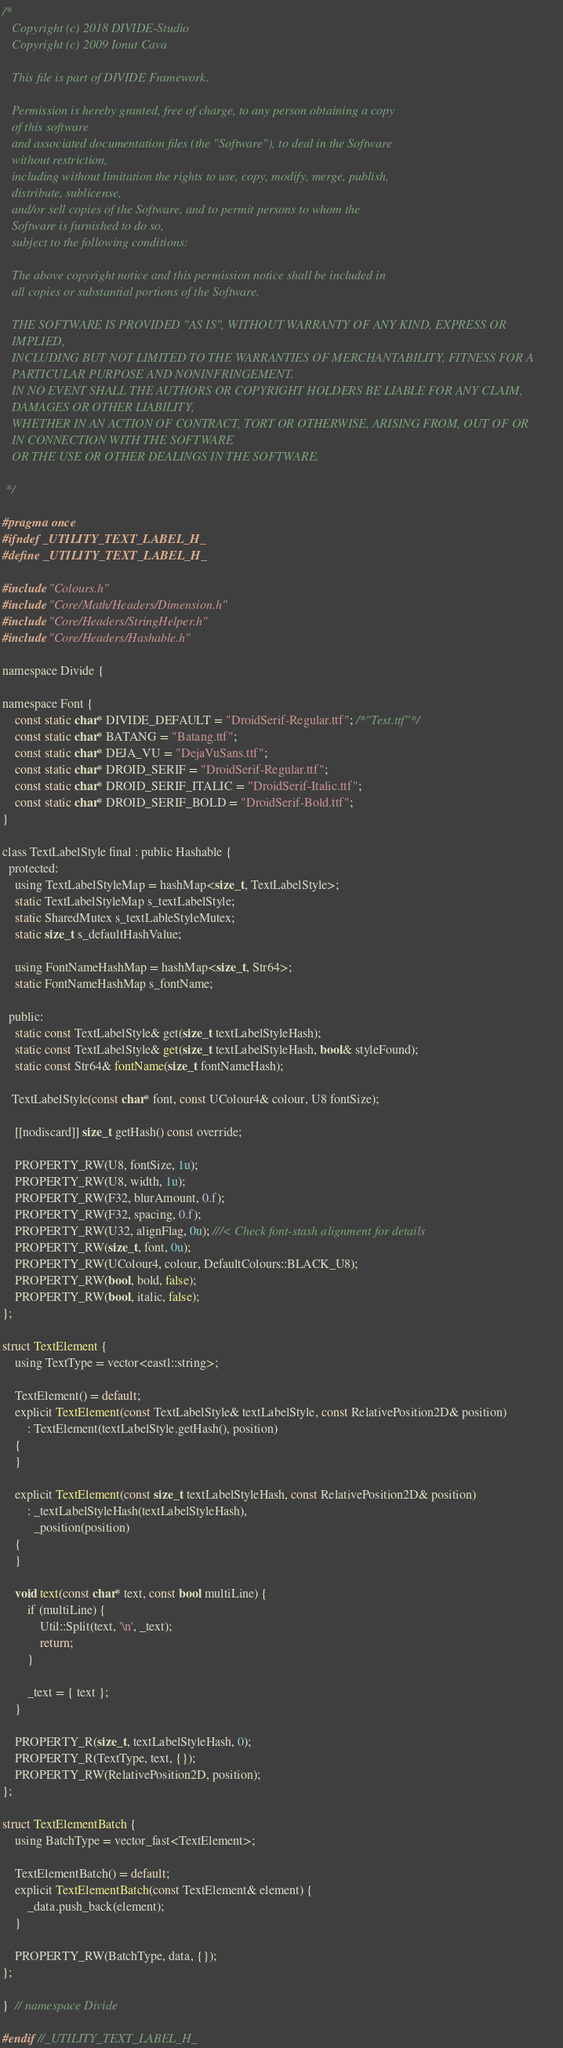<code> <loc_0><loc_0><loc_500><loc_500><_C_>/*
   Copyright (c) 2018 DIVIDE-Studio
   Copyright (c) 2009 Ionut Cava

   This file is part of DIVIDE Framework.

   Permission is hereby granted, free of charge, to any person obtaining a copy
   of this software
   and associated documentation files (the "Software"), to deal in the Software
   without restriction,
   including without limitation the rights to use, copy, modify, merge, publish,
   distribute, sublicense,
   and/or sell copies of the Software, and to permit persons to whom the
   Software is furnished to do so,
   subject to the following conditions:

   The above copyright notice and this permission notice shall be included in
   all copies or substantial portions of the Software.

   THE SOFTWARE IS PROVIDED "AS IS", WITHOUT WARRANTY OF ANY KIND, EXPRESS OR
   IMPLIED,
   INCLUDING BUT NOT LIMITED TO THE WARRANTIES OF MERCHANTABILITY, FITNESS FOR A
   PARTICULAR PURPOSE AND NONINFRINGEMENT.
   IN NO EVENT SHALL THE AUTHORS OR COPYRIGHT HOLDERS BE LIABLE FOR ANY CLAIM,
   DAMAGES OR OTHER LIABILITY,
   WHETHER IN AN ACTION OF CONTRACT, TORT OR OTHERWISE, ARISING FROM, OUT OF OR
   IN CONNECTION WITH THE SOFTWARE
   OR THE USE OR OTHER DEALINGS IN THE SOFTWARE.

 */

#pragma once
#ifndef _UTILITY_TEXT_LABEL_H_
#define _UTILITY_TEXT_LABEL_H_

#include "Colours.h"
#include "Core/Math/Headers/Dimension.h"
#include "Core/Headers/StringHelper.h"
#include "Core/Headers/Hashable.h"

namespace Divide {

namespace Font {
    const static char* DIVIDE_DEFAULT = "DroidSerif-Regular.ttf"; /*"Test.ttf"*/
    const static char* BATANG = "Batang.ttf";
    const static char* DEJA_VU = "DejaVuSans.ttf";
    const static char* DROID_SERIF = "DroidSerif-Regular.ttf";
    const static char* DROID_SERIF_ITALIC = "DroidSerif-Italic.ttf";
    const static char* DROID_SERIF_BOLD = "DroidSerif-Bold.ttf";
}

class TextLabelStyle final : public Hashable {
  protected:
    using TextLabelStyleMap = hashMap<size_t, TextLabelStyle>;
    static TextLabelStyleMap s_textLabelStyle;
    static SharedMutex s_textLableStyleMutex;
    static size_t s_defaultHashValue;

    using FontNameHashMap = hashMap<size_t, Str64>;
    static FontNameHashMap s_fontName;

  public:
    static const TextLabelStyle& get(size_t textLabelStyleHash);
    static const TextLabelStyle& get(size_t textLabelStyleHash, bool& styleFound);
    static const Str64& fontName(size_t fontNameHash);

   TextLabelStyle(const char* font, const UColour4& colour, U8 fontSize);

    [[nodiscard]] size_t getHash() const override;

    PROPERTY_RW(U8, fontSize, 1u);
    PROPERTY_RW(U8, width, 1u);
    PROPERTY_RW(F32, blurAmount, 0.f);
    PROPERTY_RW(F32, spacing, 0.f);
    PROPERTY_RW(U32, alignFlag, 0u); ///< Check font-stash alignment for details
    PROPERTY_RW(size_t, font, 0u);
    PROPERTY_RW(UColour4, colour, DefaultColours::BLACK_U8);
    PROPERTY_RW(bool, bold, false);
    PROPERTY_RW(bool, italic, false);
};

struct TextElement {
    using TextType = vector<eastl::string>;

    TextElement() = default;
    explicit TextElement(const TextLabelStyle& textLabelStyle, const RelativePosition2D& position)
        : TextElement(textLabelStyle.getHash(), position)
    {
    }

    explicit TextElement(const size_t textLabelStyleHash, const RelativePosition2D& position)
        : _textLabelStyleHash(textLabelStyleHash),
          _position(position)
    {
    }

    void text(const char* text, const bool multiLine) {
        if (multiLine) {
            Util::Split(text, '\n', _text);
            return;
        }

        _text = { text };
    }

    PROPERTY_R(size_t, textLabelStyleHash, 0);
    PROPERTY_R(TextType, text, {});
    PROPERTY_RW(RelativePosition2D, position);
};

struct TextElementBatch {
    using BatchType = vector_fast<TextElement>;

    TextElementBatch() = default;
    explicit TextElementBatch(const TextElement& element) {
        _data.push_back(element);
    }

    PROPERTY_RW(BatchType, data, {});
};

}  // namespace Divide

#endif //_UTILITY_TEXT_LABEL_H_</code> 